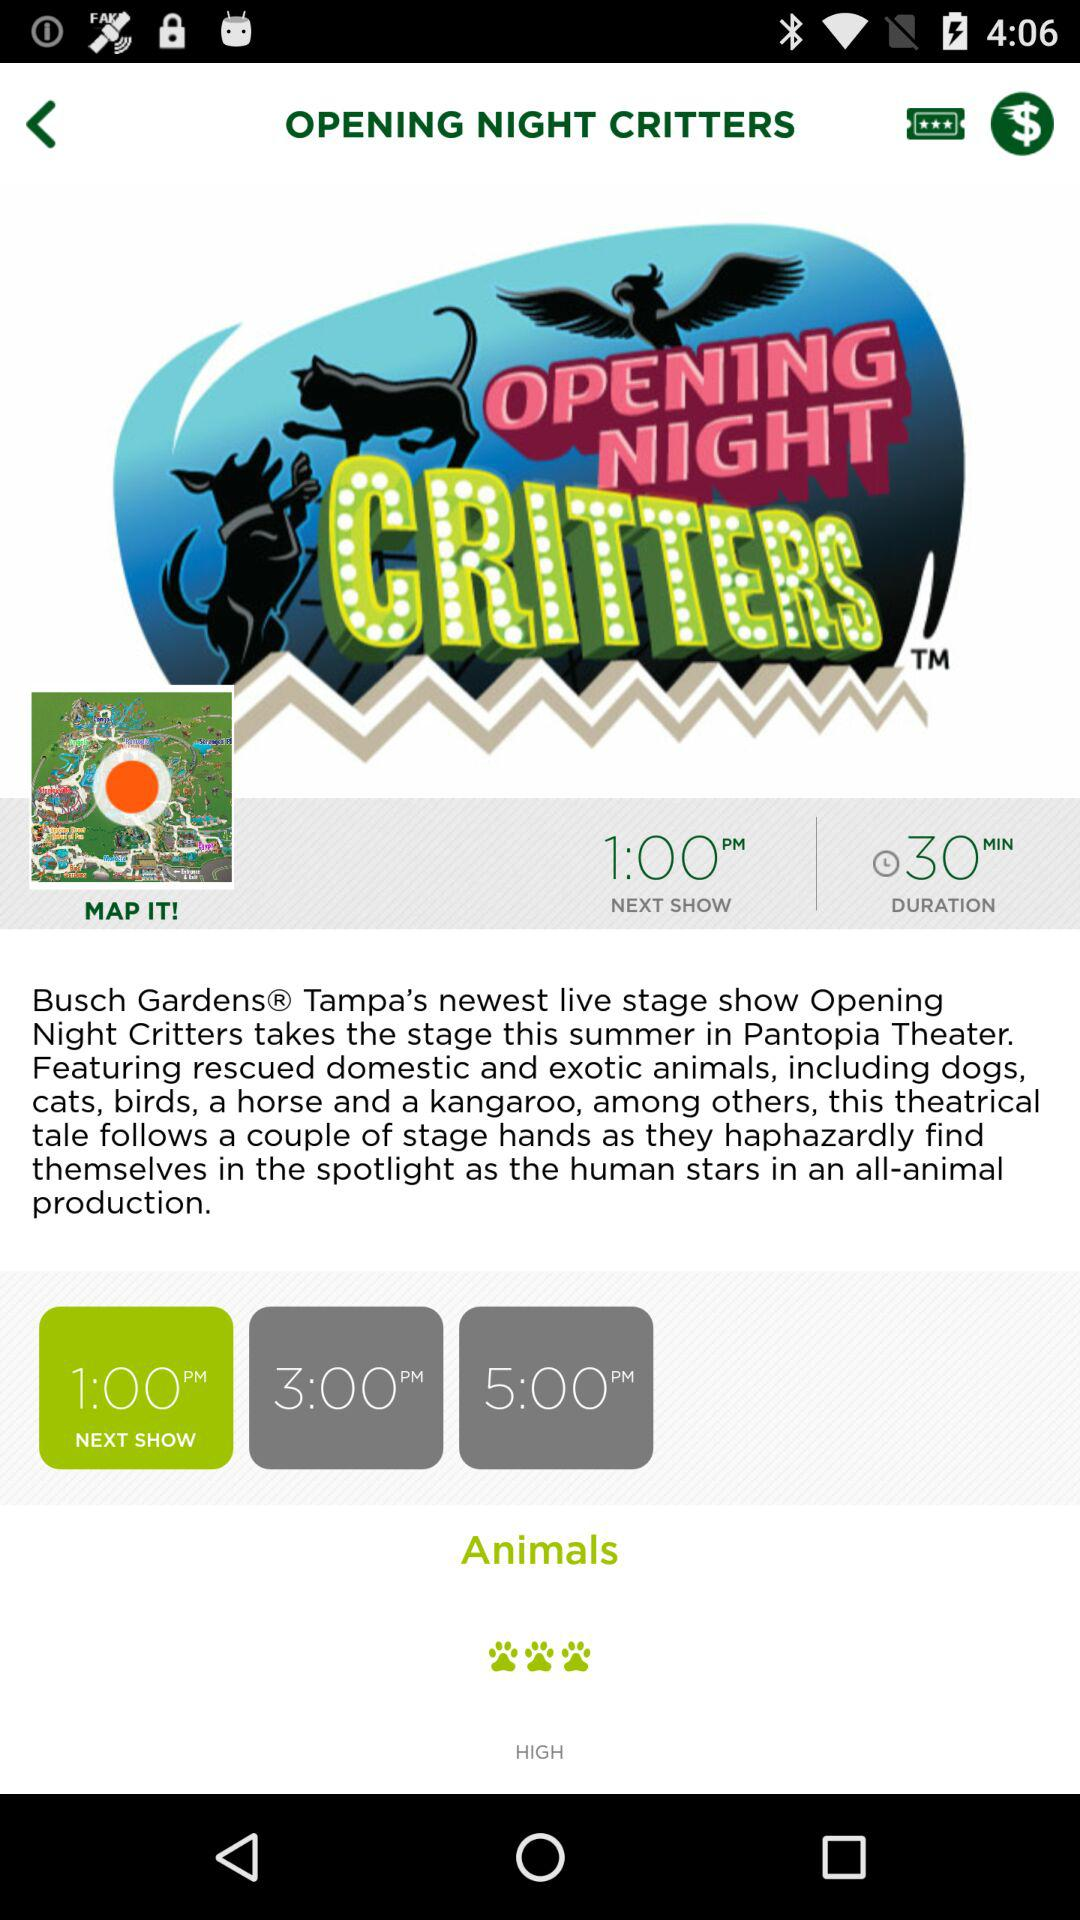What is the duration of the show? The duration of the show is 30 minutes. 